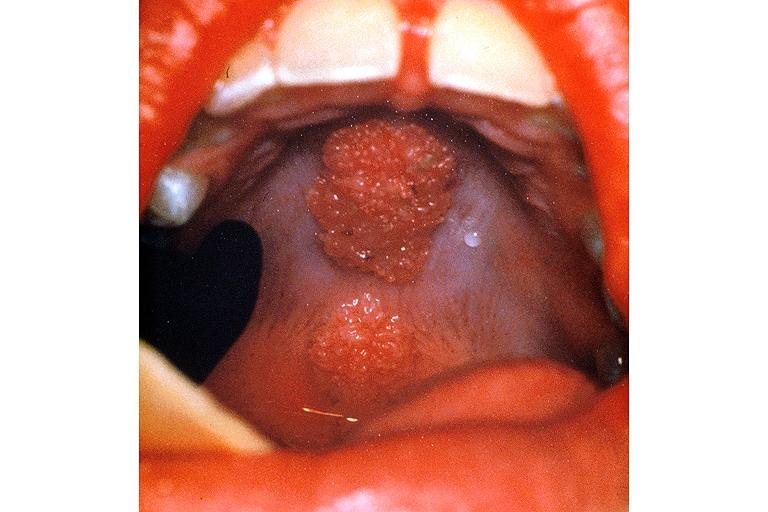s oral present?
Answer the question using a single word or phrase. Yes 